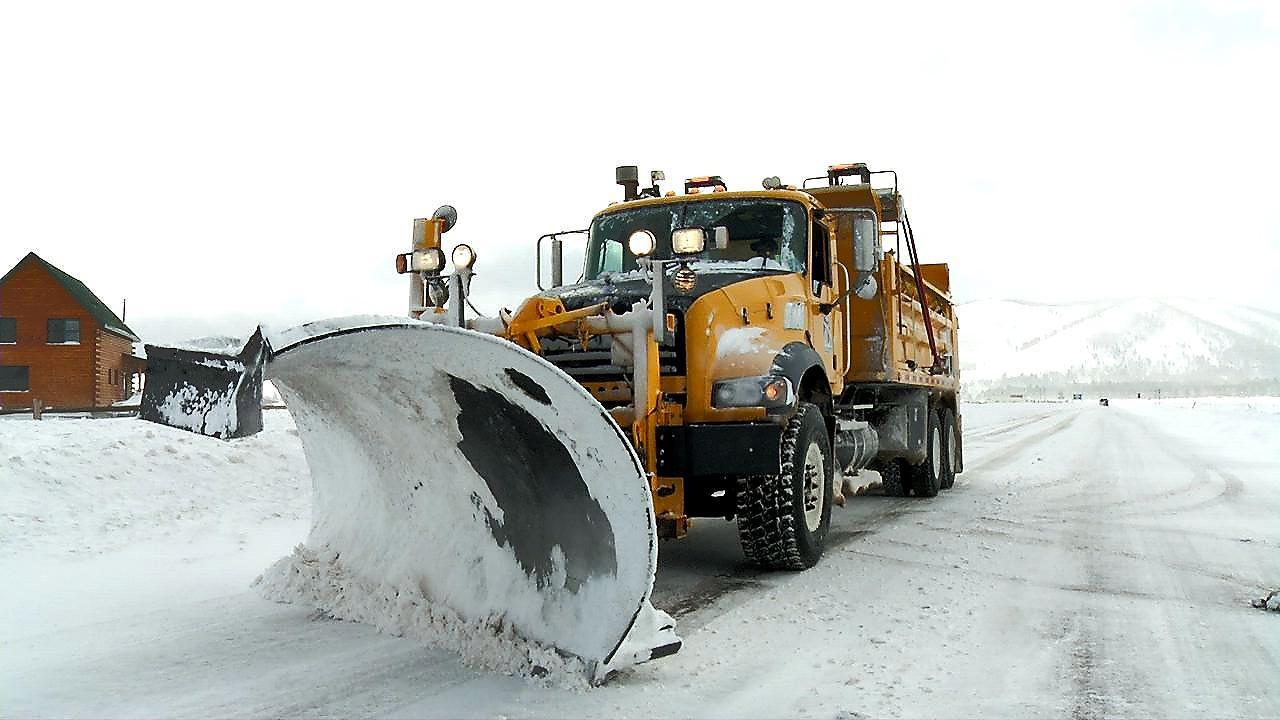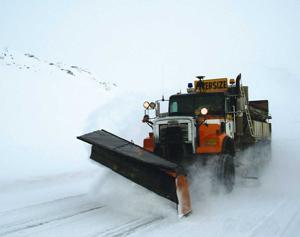The first image is the image on the left, the second image is the image on the right. Evaluate the accuracy of this statement regarding the images: "The plow on the truck in the left image is yellow.". Is it true? Answer yes or no. No. The first image is the image on the left, the second image is the image on the right. For the images shown, is this caption "there are two bulldozers facing the same direction" true? Answer yes or no. Yes. 